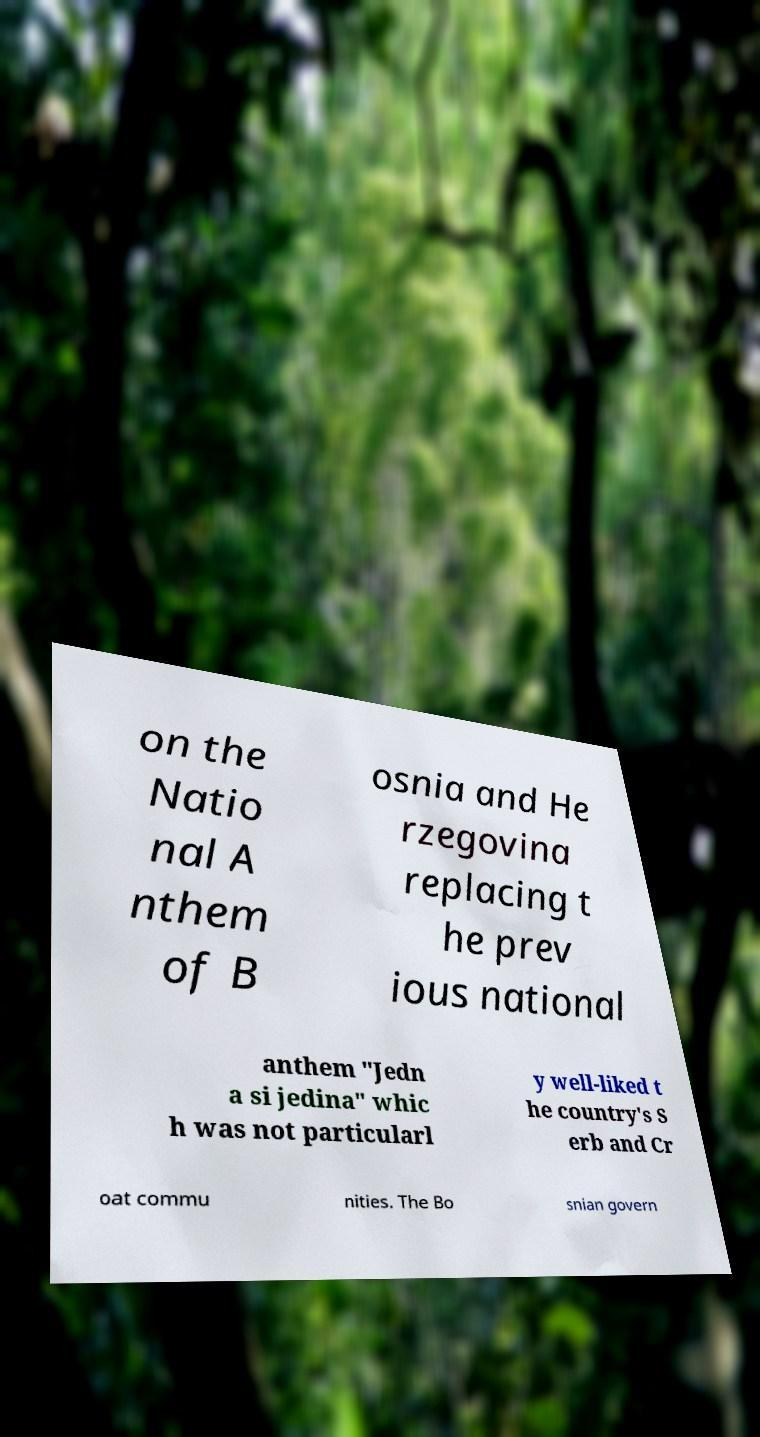I need the written content from this picture converted into text. Can you do that? on the Natio nal A nthem of B osnia and He rzegovina replacing t he prev ious national anthem "Jedn a si jedina" whic h was not particularl y well-liked t he country's S erb and Cr oat commu nities. The Bo snian govern 